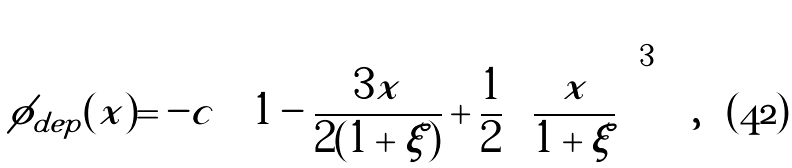<formula> <loc_0><loc_0><loc_500><loc_500>\phi _ { d e p } ( x ) = - c \left [ 1 - \frac { 3 x } { 2 ( 1 + \xi ) } + \frac { 1 } { 2 } \left ( \frac { x } { 1 + \xi } \right ) ^ { 3 } \right ] ,</formula> 